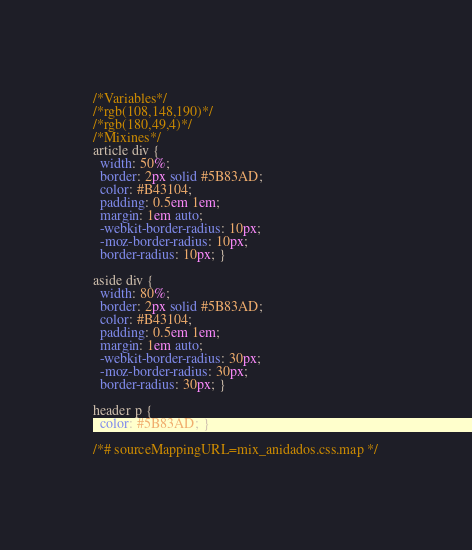Convert code to text. <code><loc_0><loc_0><loc_500><loc_500><_CSS_>/*Variables*/
/*rgb(108,148,190)*/
/*rgb(180,49,4)*/
/*Mixines*/
article div {
  width: 50%;
  border: 2px solid #5B83AD;
  color: #B43104;
  padding: 0.5em 1em;
  margin: 1em auto;
  -webkit-border-radius: 10px;
  -moz-border-radius: 10px;
  border-radius: 10px; }

aside div {
  width: 80%;
  border: 2px solid #5B83AD;
  color: #B43104;
  padding: 0.5em 1em;
  margin: 1em auto;
  -webkit-border-radius: 30px;
  -moz-border-radius: 30px;
  border-radius: 30px; }

header p {
  color: #5B83AD; }

/*# sourceMappingURL=mix_anidados.css.map */
</code> 